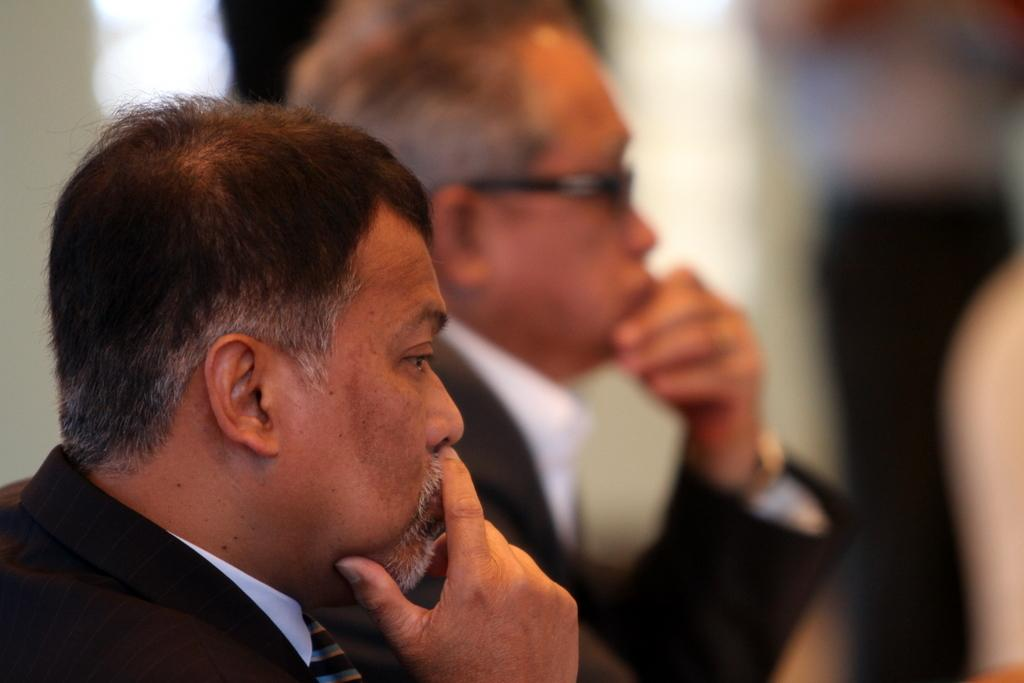How many people are in the image? There are two persons in the image. Can you describe the background of the image? The background of the image is blurred. What type of produce can be seen in the image? There is no produce present in the image. What shape is the goat in the image? There is no goat present in the image. 